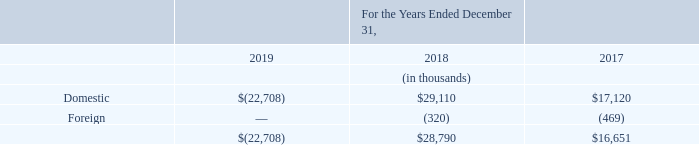NOTE 13 – INCOME TAX
The domestic and foreign components of loss before income taxes from operations for the years ended December 31, 2019, 2018 and 2017 are as follows:
What are the respective domestic income before income taxes in 2018 and 2017? 
Answer scale should be: thousand. 29,110, 17,120. What are the respective foreign income loss before income taxes in 2017 and 2018?
Answer scale should be: thousand. 469, 320. What are the respective total income before tax in 2017 and 2018?
Answer scale should be: thousand. $16,651, $28,790. What is the percentage change in total income before tax between 2017 and 2018?
Answer scale should be: percent. (28,790-16,651)/16,651
Answer: 72.9. What is the average income before tax in 2017 and 2018?
Answer scale should be: thousand. (16,651 + 28,790)/2 
Answer: 22720.5. What is the total foreign component of loss before income tax in 2017 and 2018?
Answer scale should be: thousand. 469 + 320 
Answer: 789. 